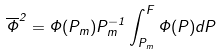<formula> <loc_0><loc_0><loc_500><loc_500>\overline { \Phi } ^ { 2 } = \Phi ( P _ { m } ) P _ { m } ^ { - 1 } \int _ { P _ { m } } ^ { F } \Phi ( P ) d P</formula> 